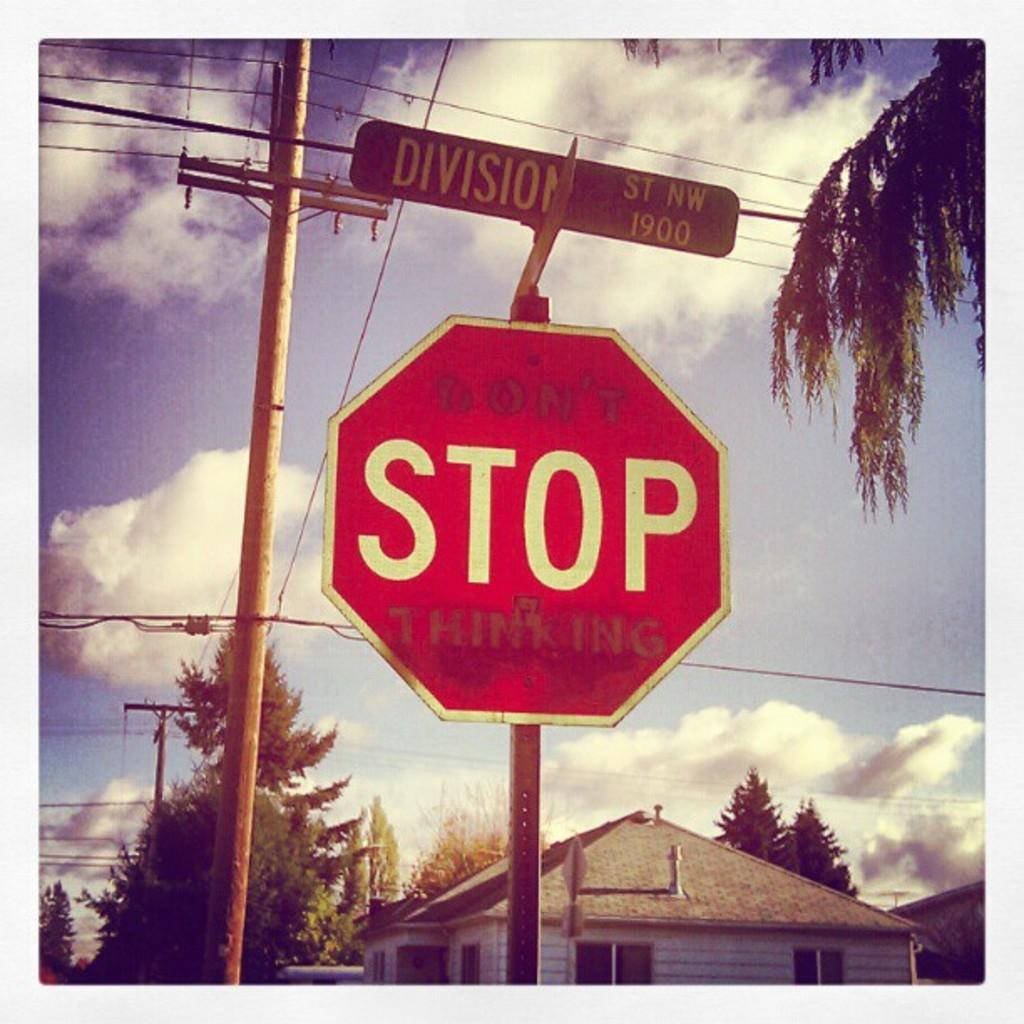<image>
Describe the image concisely. A stop sign at the corner of Division Street. 